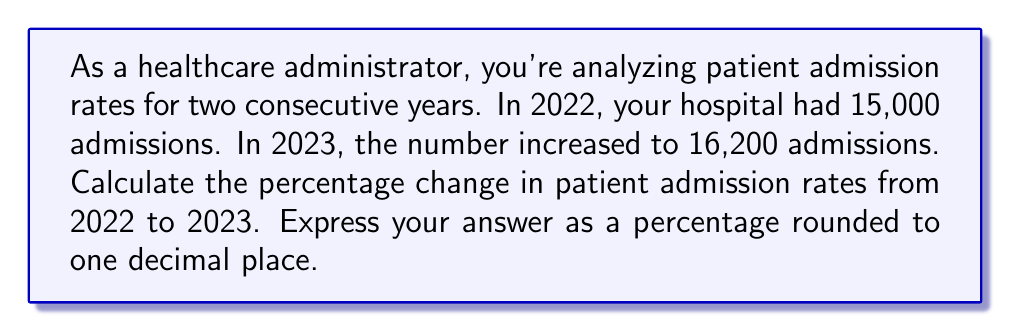What is the answer to this math problem? To calculate the percentage change in patient admission rates, we'll use the following formula:

$$ \text{Percentage Change} = \frac{\text{New Value} - \text{Original Value}}{\text{Original Value}} \times 100\% $$

Let's plug in our values:
- Original Value (2022 admissions): 15,000
- New Value (2023 admissions): 16,200

$$ \text{Percentage Change} = \frac{16,200 - 15,000}{15,000} \times 100\% $$

$$ = \frac{1,200}{15,000} \times 100\% $$

$$ = 0.08 \times 100\% $$

$$ = 8\% $$

The exact percentage change is 8%. Rounding to one decimal place, we get 8.0%.
Answer: 8.0% 